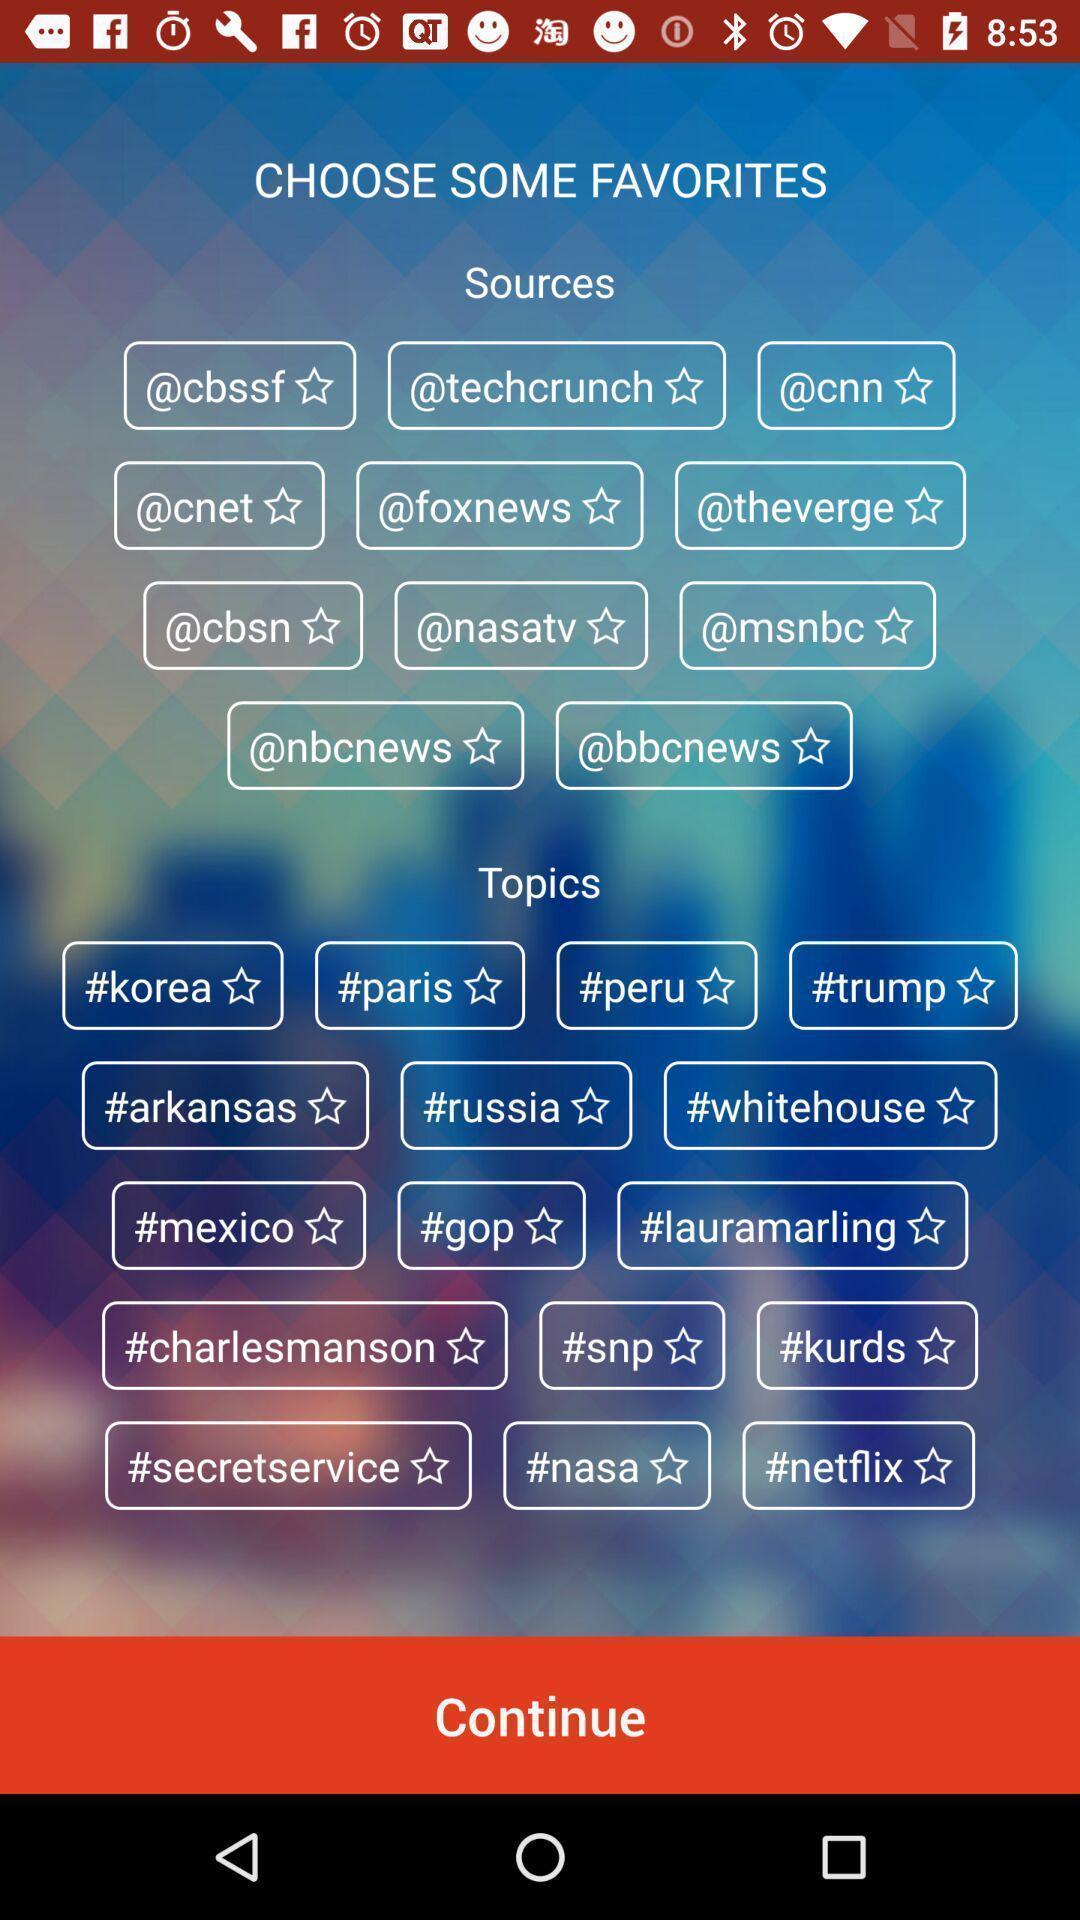What is the overall content of this screenshot? Page showing option like continue. 